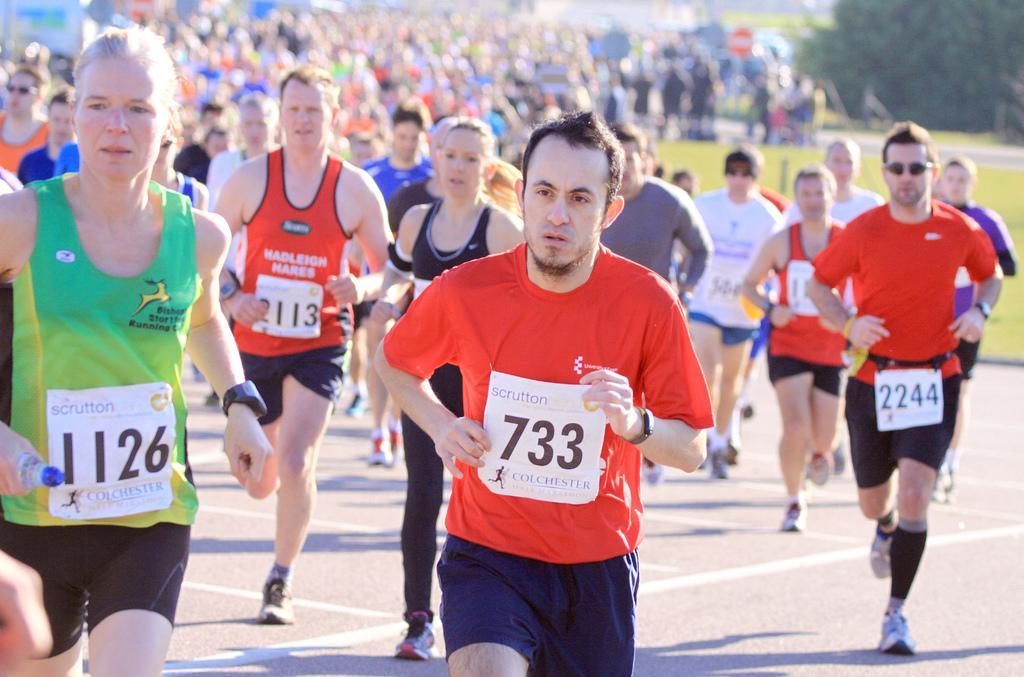In one or two sentences, can you explain what this image depicts? In the image there are many people running on the road. There are white papers with numbers attached on their dresses. In the background there are trees and there's grass on the ground. 